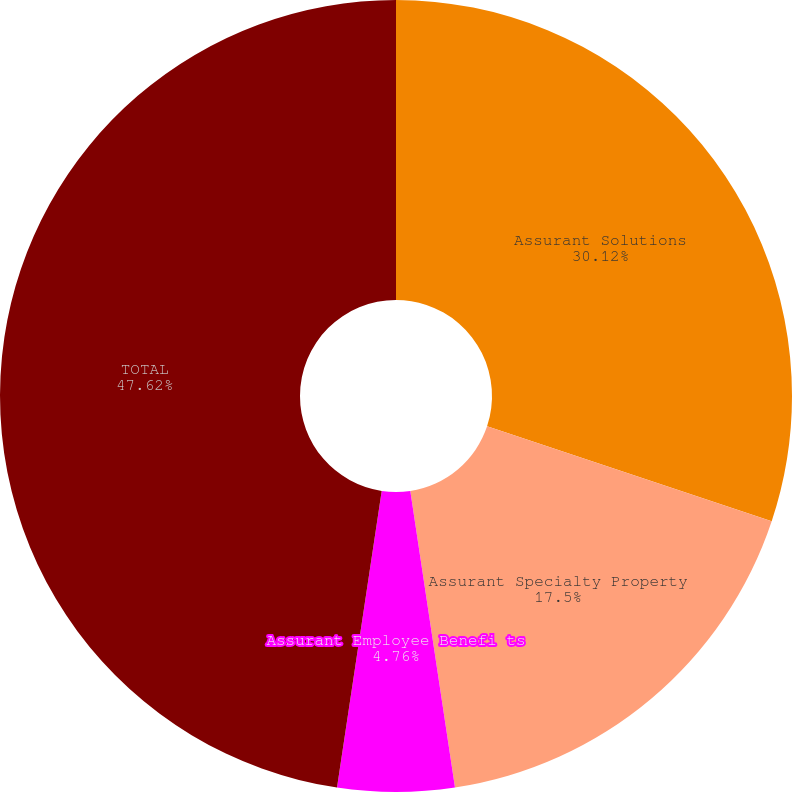Convert chart to OTSL. <chart><loc_0><loc_0><loc_500><loc_500><pie_chart><fcel>Assurant Solutions<fcel>Assurant Specialty Property<fcel>Assurant Health<fcel>Assurant Employee Benefi ts<fcel>TOTAL<nl><fcel>30.12%<fcel>17.5%<fcel>0.0%<fcel>4.76%<fcel>47.62%<nl></chart> 